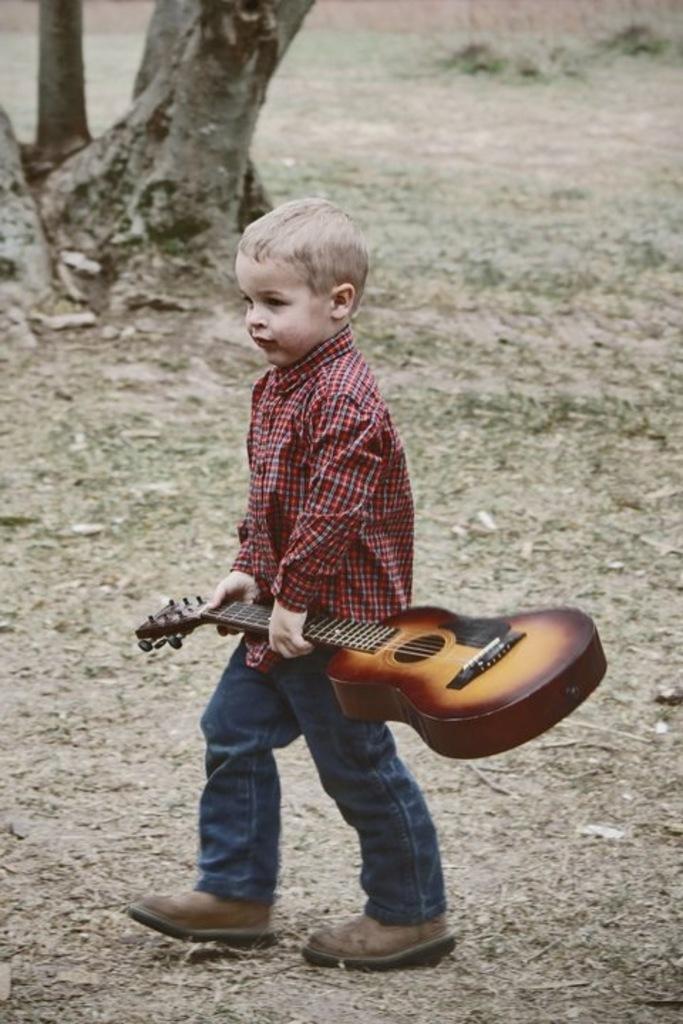Please provide a concise description of this image. In this image I see a boy who is holding a guitar and standing on the ground. In the background I see a tree. 